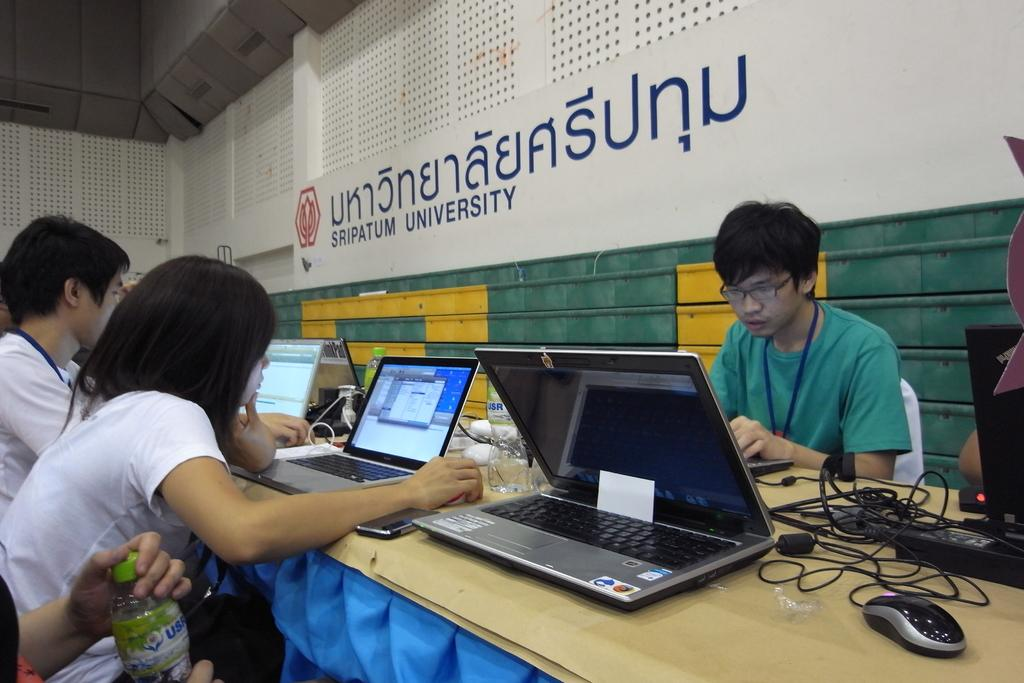<image>
Write a terse but informative summary of the picture. A group of students working on laptops at Sripatum University 